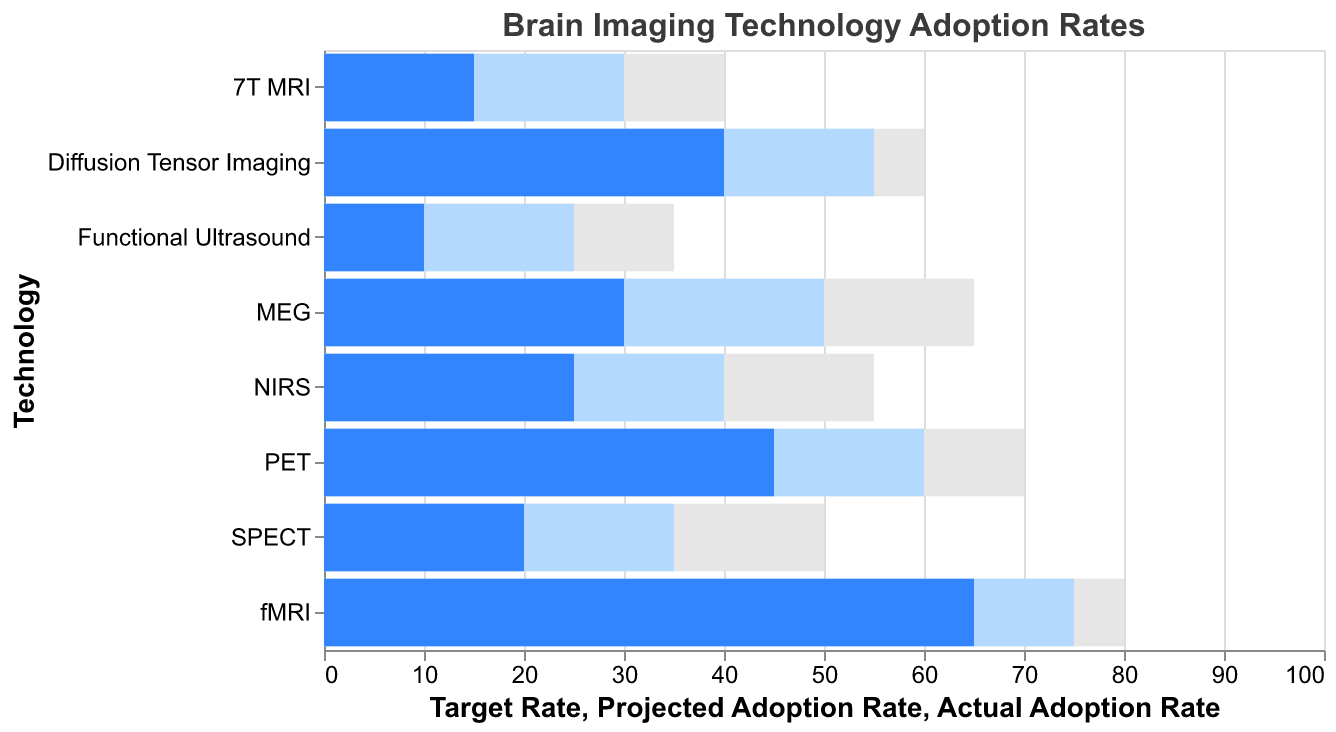What is the actual adoption rate of fMRI? The figure shows that the actual adoption rate is represented by the darkest bar for each technology. For fMRI, the darkest bar corresponds to 65.
Answer: 65 Which technology has the lowest actual adoption rate? Look for the darkest bar with the smallest value among all the technologies. The smallest value is for Functional Ultrasound.
Answer: Functional Ultrasound How much higher is the projected adoption rate of PET compared to MEG? Find the projected adoption rates for PET and MEG, which are 60 and 50, respectively. Calculate the difference: 60 - 50 = 10.
Answer: 10 What is the target rate for NIRS? Find the lightest bar for NIRS, which indicates the target rate. The bar corresponds to 55.
Answer: 55 Between Diffusion Tensor Imaging and SPECT, which technology has a higher actual adoption rate? Compare the darkest bars for Diffusion Tensor Imaging (40) and SPECT (20). The higher rate is for Diffusion Tensor Imaging.
Answer: Diffusion Tensor Imaging Which technology is closest to reaching its target rate based on actual adoption? Calculate the difference between the target rate and the actual rate for each technology. fMRI has a target of 80 and an actual rate of 65, so the difference is 15. This is the smallest difference among all technologies.
Answer: fMRI How much lower is the actual adoption rate of 7T MRI compared to its target rate? Identify the actual adoption rate and target rate for 7T MRI, which are 15 and 40 respectively. Calculate the difference: 40 - 15 = 25.
Answer: 25 By how much does the projected adoption rate of fMRI exceed the actual adoption rate? Look at the projected adoption rate for fMRI, which is 75, and the actual adoption rate, which is 65. Calculate the difference: 75 - 65 = 10.
Answer: 10 Which technology has the greatest gap between projected adoption rate and target rate? Calculate the difference between the target rate and the projected rate for each technology. The largest difference is in SPECT, with target 50 and projected 35, giving a difference of 15.
Answer: SPECT If you were to average the actual adoption rates of fMRI, PET, and MEG, what would it be? Add the actual adoption rates for fMRI (65), PET (45), and MEG (30), then divide by 3: (65 + 45 + 30) / 3 = 140 / 3 ≈ 46.67.
Answer: 46.67 